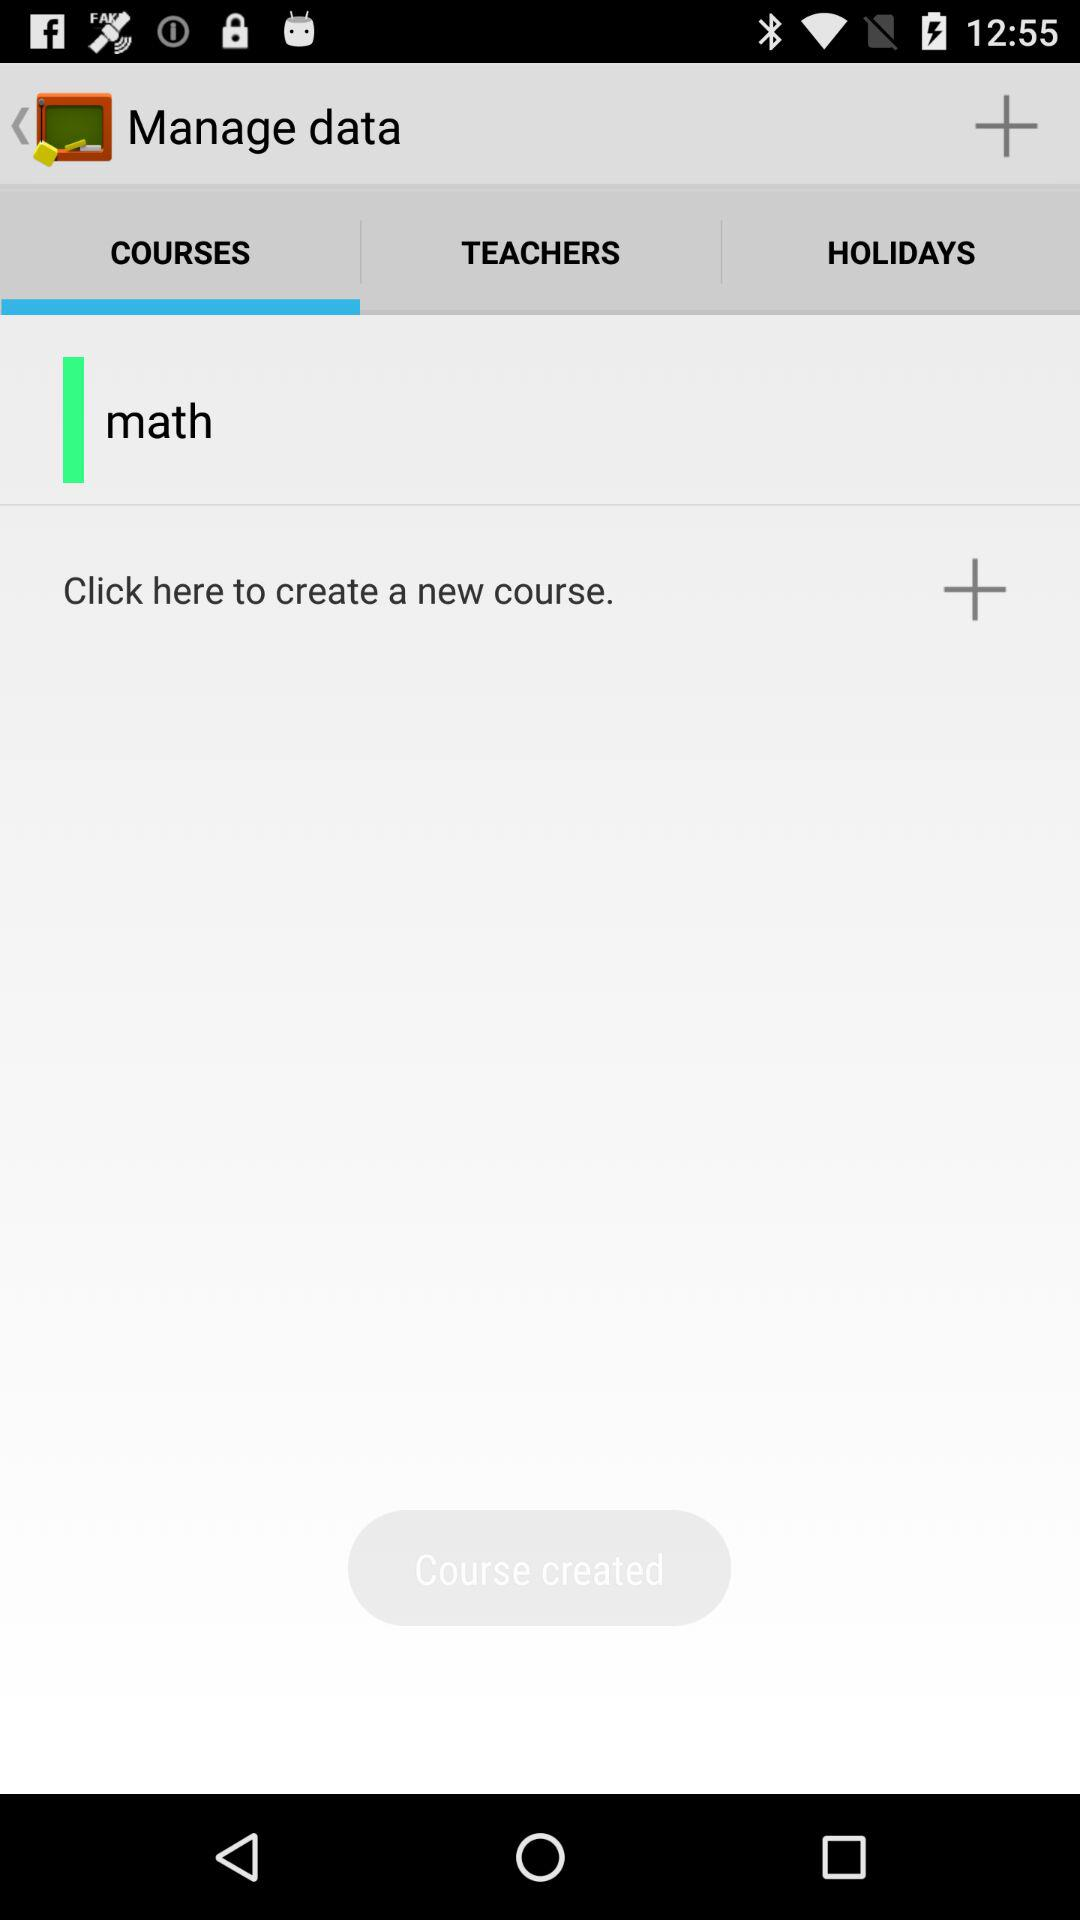What is the application name?
When the provided information is insufficient, respond with <no answer>. <no answer> 